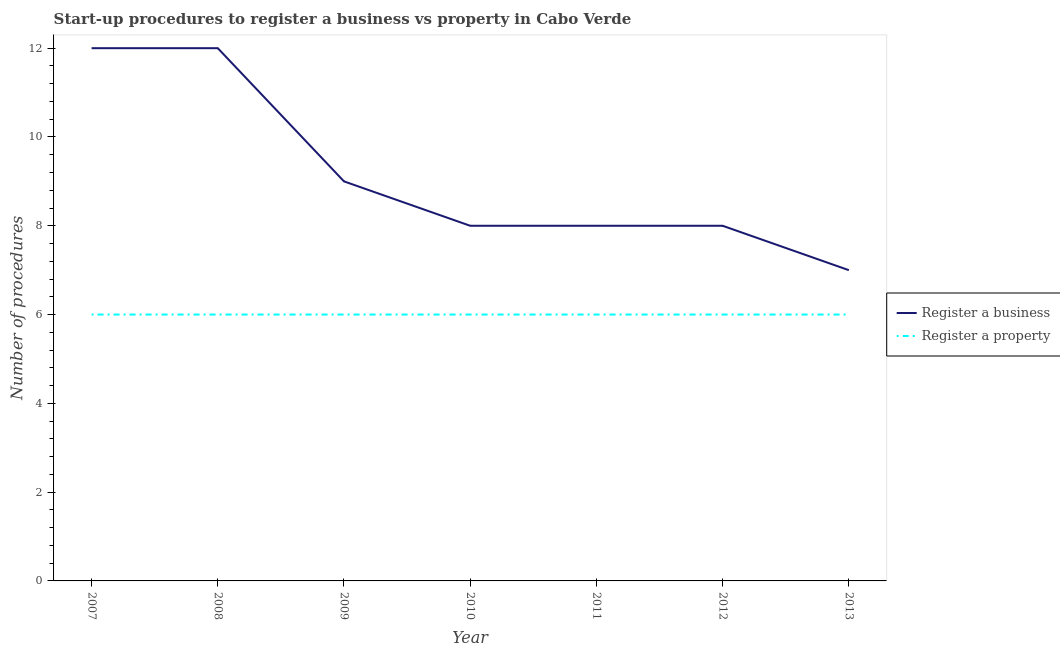How many different coloured lines are there?
Your response must be concise. 2. Is the number of lines equal to the number of legend labels?
Provide a short and direct response. Yes. What is the number of procedures to register a business in 2012?
Make the answer very short. 8. Across all years, what is the maximum number of procedures to register a property?
Make the answer very short. 6. Across all years, what is the minimum number of procedures to register a business?
Provide a succinct answer. 7. What is the total number of procedures to register a property in the graph?
Make the answer very short. 42. What is the difference between the number of procedures to register a property in 2011 and the number of procedures to register a business in 2013?
Make the answer very short. -1. What is the average number of procedures to register a business per year?
Keep it short and to the point. 9.14. In the year 2011, what is the difference between the number of procedures to register a property and number of procedures to register a business?
Keep it short and to the point. -2. In how many years, is the number of procedures to register a property greater than 2?
Provide a succinct answer. 7. Is the number of procedures to register a property in 2010 less than that in 2013?
Ensure brevity in your answer.  No. In how many years, is the number of procedures to register a property greater than the average number of procedures to register a property taken over all years?
Your answer should be compact. 0. Are the values on the major ticks of Y-axis written in scientific E-notation?
Your answer should be compact. No. Does the graph contain grids?
Provide a succinct answer. No. What is the title of the graph?
Provide a short and direct response. Start-up procedures to register a business vs property in Cabo Verde. Does "Overweight" appear as one of the legend labels in the graph?
Offer a very short reply. No. What is the label or title of the Y-axis?
Provide a succinct answer. Number of procedures. What is the Number of procedures of Register a business in 2007?
Keep it short and to the point. 12. What is the Number of procedures of Register a property in 2007?
Offer a very short reply. 6. What is the Number of procedures in Register a business in 2009?
Your answer should be very brief. 9. What is the Number of procedures in Register a business in 2010?
Your answer should be compact. 8. What is the Number of procedures in Register a property in 2010?
Your answer should be very brief. 6. What is the Number of procedures of Register a property in 2011?
Provide a short and direct response. 6. What is the Number of procedures of Register a business in 2013?
Your response must be concise. 7. What is the Number of procedures in Register a property in 2013?
Make the answer very short. 6. Across all years, what is the maximum Number of procedures in Register a business?
Keep it short and to the point. 12. Across all years, what is the maximum Number of procedures of Register a property?
Your answer should be compact. 6. What is the difference between the Number of procedures of Register a business in 2007 and that in 2008?
Ensure brevity in your answer.  0. What is the difference between the Number of procedures in Register a property in 2007 and that in 2008?
Ensure brevity in your answer.  0. What is the difference between the Number of procedures of Register a property in 2007 and that in 2009?
Keep it short and to the point. 0. What is the difference between the Number of procedures of Register a business in 2007 and that in 2010?
Your answer should be compact. 4. What is the difference between the Number of procedures in Register a property in 2007 and that in 2010?
Provide a short and direct response. 0. What is the difference between the Number of procedures in Register a business in 2007 and that in 2012?
Your answer should be compact. 4. What is the difference between the Number of procedures of Register a business in 2008 and that in 2009?
Your response must be concise. 3. What is the difference between the Number of procedures of Register a business in 2008 and that in 2011?
Ensure brevity in your answer.  4. What is the difference between the Number of procedures in Register a property in 2008 and that in 2013?
Keep it short and to the point. 0. What is the difference between the Number of procedures in Register a property in 2009 and that in 2011?
Keep it short and to the point. 0. What is the difference between the Number of procedures in Register a business in 2009 and that in 2012?
Ensure brevity in your answer.  1. What is the difference between the Number of procedures of Register a property in 2010 and that in 2012?
Offer a very short reply. 0. What is the difference between the Number of procedures in Register a business in 2010 and that in 2013?
Offer a terse response. 1. What is the difference between the Number of procedures of Register a property in 2011 and that in 2013?
Offer a terse response. 0. What is the difference between the Number of procedures in Register a property in 2012 and that in 2013?
Give a very brief answer. 0. What is the difference between the Number of procedures in Register a business in 2007 and the Number of procedures in Register a property in 2008?
Offer a very short reply. 6. What is the difference between the Number of procedures in Register a business in 2007 and the Number of procedures in Register a property in 2011?
Make the answer very short. 6. What is the difference between the Number of procedures in Register a business in 2008 and the Number of procedures in Register a property in 2009?
Make the answer very short. 6. What is the difference between the Number of procedures of Register a business in 2008 and the Number of procedures of Register a property in 2011?
Offer a terse response. 6. What is the difference between the Number of procedures of Register a business in 2008 and the Number of procedures of Register a property in 2012?
Provide a succinct answer. 6. What is the difference between the Number of procedures of Register a business in 2009 and the Number of procedures of Register a property in 2010?
Provide a succinct answer. 3. What is the difference between the Number of procedures in Register a business in 2009 and the Number of procedures in Register a property in 2011?
Ensure brevity in your answer.  3. What is the difference between the Number of procedures in Register a business in 2009 and the Number of procedures in Register a property in 2012?
Keep it short and to the point. 3. What is the difference between the Number of procedures of Register a business in 2009 and the Number of procedures of Register a property in 2013?
Offer a terse response. 3. What is the difference between the Number of procedures in Register a business in 2011 and the Number of procedures in Register a property in 2012?
Give a very brief answer. 2. What is the difference between the Number of procedures in Register a business in 2011 and the Number of procedures in Register a property in 2013?
Your answer should be compact. 2. What is the average Number of procedures in Register a business per year?
Your answer should be very brief. 9.14. What is the average Number of procedures in Register a property per year?
Give a very brief answer. 6. In the year 2009, what is the difference between the Number of procedures in Register a business and Number of procedures in Register a property?
Keep it short and to the point. 3. In the year 2013, what is the difference between the Number of procedures in Register a business and Number of procedures in Register a property?
Provide a short and direct response. 1. What is the ratio of the Number of procedures of Register a property in 2007 to that in 2008?
Provide a succinct answer. 1. What is the ratio of the Number of procedures of Register a business in 2007 to that in 2009?
Keep it short and to the point. 1.33. What is the ratio of the Number of procedures of Register a business in 2007 to that in 2011?
Your answer should be very brief. 1.5. What is the ratio of the Number of procedures of Register a business in 2007 to that in 2012?
Your answer should be compact. 1.5. What is the ratio of the Number of procedures in Register a business in 2007 to that in 2013?
Your answer should be compact. 1.71. What is the ratio of the Number of procedures of Register a property in 2007 to that in 2013?
Keep it short and to the point. 1. What is the ratio of the Number of procedures of Register a business in 2008 to that in 2010?
Provide a succinct answer. 1.5. What is the ratio of the Number of procedures of Register a property in 2008 to that in 2010?
Give a very brief answer. 1. What is the ratio of the Number of procedures in Register a business in 2008 to that in 2012?
Your response must be concise. 1.5. What is the ratio of the Number of procedures of Register a property in 2008 to that in 2012?
Make the answer very short. 1. What is the ratio of the Number of procedures of Register a business in 2008 to that in 2013?
Provide a succinct answer. 1.71. What is the ratio of the Number of procedures in Register a property in 2008 to that in 2013?
Keep it short and to the point. 1. What is the ratio of the Number of procedures in Register a business in 2009 to that in 2011?
Your response must be concise. 1.12. What is the ratio of the Number of procedures in Register a business in 2009 to that in 2012?
Your response must be concise. 1.12. What is the ratio of the Number of procedures in Register a business in 2009 to that in 2013?
Keep it short and to the point. 1.29. What is the ratio of the Number of procedures in Register a property in 2010 to that in 2011?
Offer a very short reply. 1. What is the ratio of the Number of procedures of Register a business in 2010 to that in 2012?
Offer a very short reply. 1. What is the ratio of the Number of procedures in Register a business in 2010 to that in 2013?
Your answer should be very brief. 1.14. What is the ratio of the Number of procedures of Register a business in 2011 to that in 2012?
Your answer should be compact. 1. What is the ratio of the Number of procedures of Register a property in 2011 to that in 2012?
Provide a short and direct response. 1. What is the ratio of the Number of procedures of Register a business in 2011 to that in 2013?
Keep it short and to the point. 1.14. What is the ratio of the Number of procedures in Register a property in 2011 to that in 2013?
Provide a succinct answer. 1. What is the difference between the highest and the second highest Number of procedures of Register a business?
Provide a short and direct response. 0. What is the difference between the highest and the second highest Number of procedures in Register a property?
Your response must be concise. 0. What is the difference between the highest and the lowest Number of procedures in Register a business?
Your response must be concise. 5. What is the difference between the highest and the lowest Number of procedures of Register a property?
Ensure brevity in your answer.  0. 